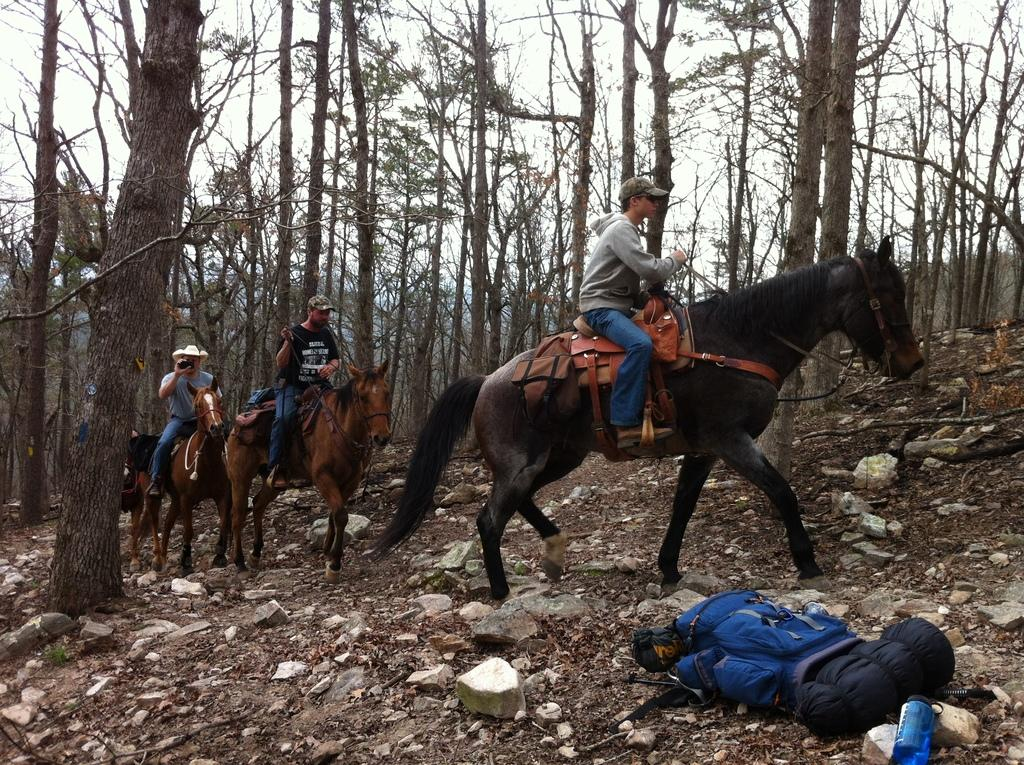What are the men in the image doing? The men in the image are riding horses. How would you describe the terrain in the image? The land is rocky. What can be seen in the background of the image? There are many trees in the background of the image. What is visible above the land and trees in the image? The sky is visible in the image. What type of underwear is the horse wearing in the image? There is no underwear present in the image, as horses do not wear clothing. What kind of wine is being served at the event in the image? There is no event or wine present in the image; it features men riding horses in a rocky landscape with many trees in the background. 